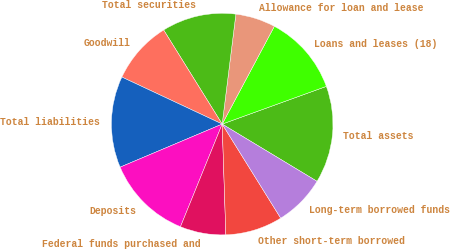Convert chart to OTSL. <chart><loc_0><loc_0><loc_500><loc_500><pie_chart><fcel>Total assets<fcel>Loans and leases (18)<fcel>Allowance for loan and lease<fcel>Total securities<fcel>Goodwill<fcel>Total liabilities<fcel>Deposits<fcel>Federal funds purchased and<fcel>Other short-term borrowed<fcel>Long-term borrowed funds<nl><fcel>14.17%<fcel>11.67%<fcel>5.83%<fcel>10.83%<fcel>9.17%<fcel>13.33%<fcel>12.5%<fcel>6.67%<fcel>8.33%<fcel>7.5%<nl></chart> 